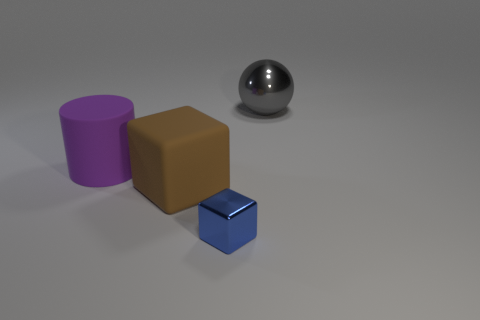Subtract all blue cubes. How many cubes are left? 1 Subtract 0 cyan spheres. How many objects are left? 4 Subtract all balls. How many objects are left? 3 Subtract 1 cubes. How many cubes are left? 1 Subtract all green cubes. Subtract all purple balls. How many cubes are left? 2 Subtract all green cylinders. How many brown cubes are left? 1 Subtract all red balls. Subtract all large rubber cubes. How many objects are left? 3 Add 4 cylinders. How many cylinders are left? 5 Add 4 small brown balls. How many small brown balls exist? 4 Add 1 big purple rubber cylinders. How many objects exist? 5 